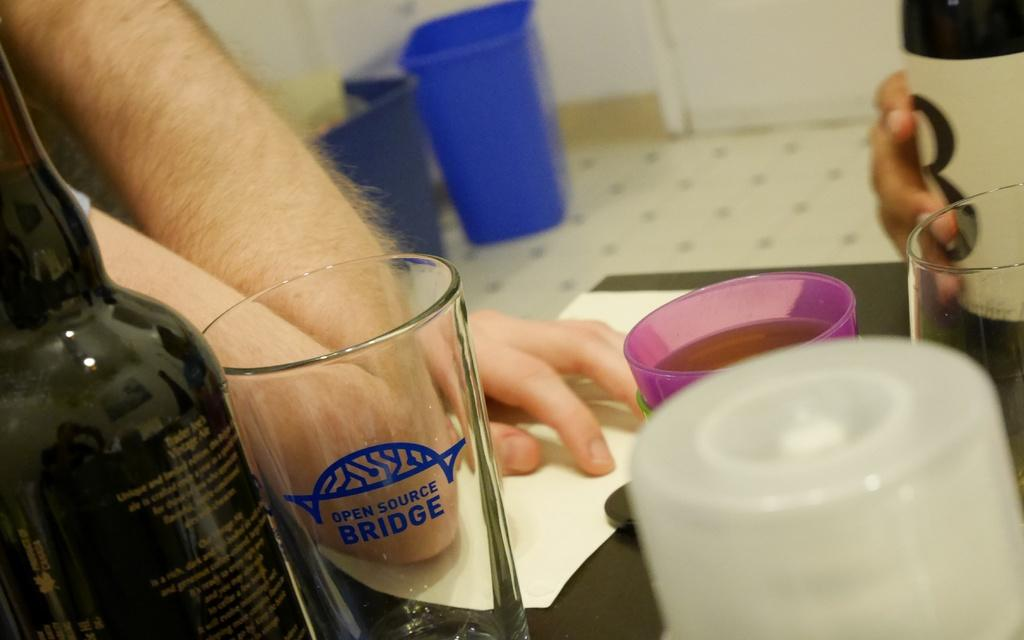<image>
Give a short and clear explanation of the subsequent image. A man resting his elbow on a table that has an empty Open Source Bridge glass next to a dark colored glass bottle. 